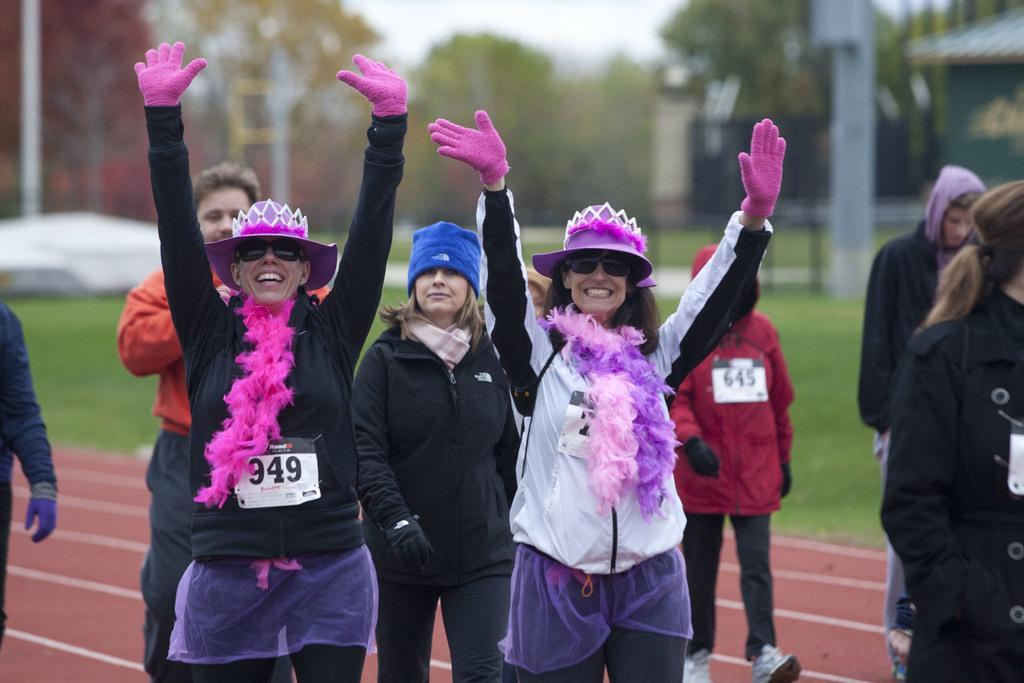Please provide a concise description of this image. In the picture we can see a running surface on it, we can see some people are standing and two women are raising their hands and they are in jackets, hoodies and gloves and in the background, we can see a grass surface with some poles and trees and a part of the sky. 